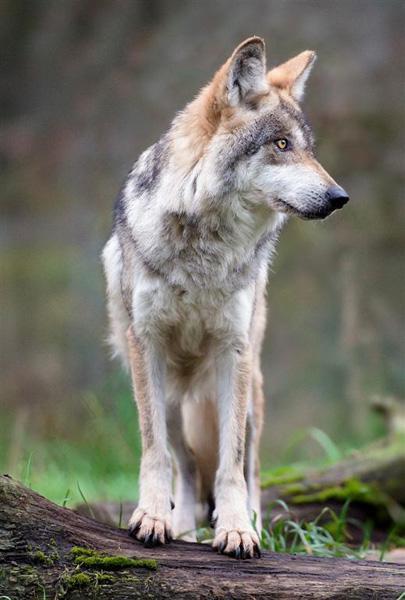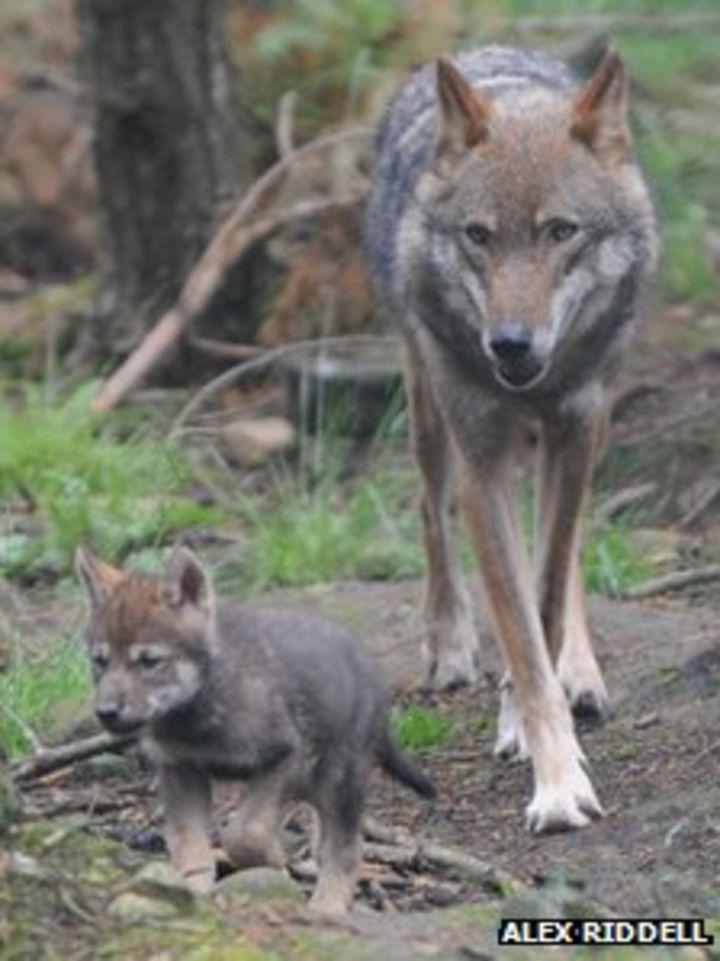The first image is the image on the left, the second image is the image on the right. Evaluate the accuracy of this statement regarding the images: "One image contains twice as many wolves as the other image.". Is it true? Answer yes or no. Yes. The first image is the image on the left, the second image is the image on the right. For the images shown, is this caption "Two wolves are hanging out together in one of the pictures." true? Answer yes or no. Yes. 